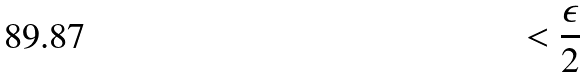<formula> <loc_0><loc_0><loc_500><loc_500>< \frac { \epsilon } { 2 }</formula> 